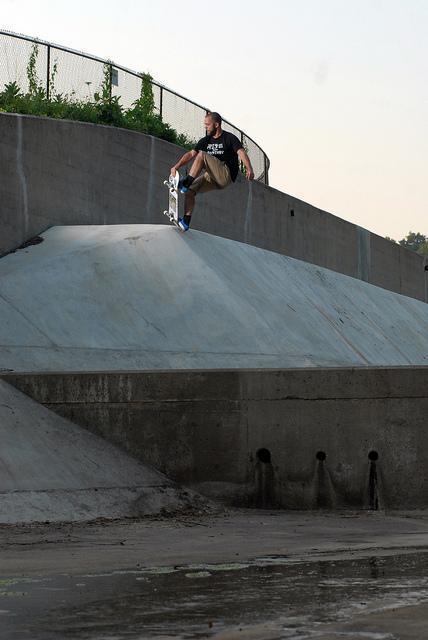How many sinks are in the bathroom?
Give a very brief answer. 0. 